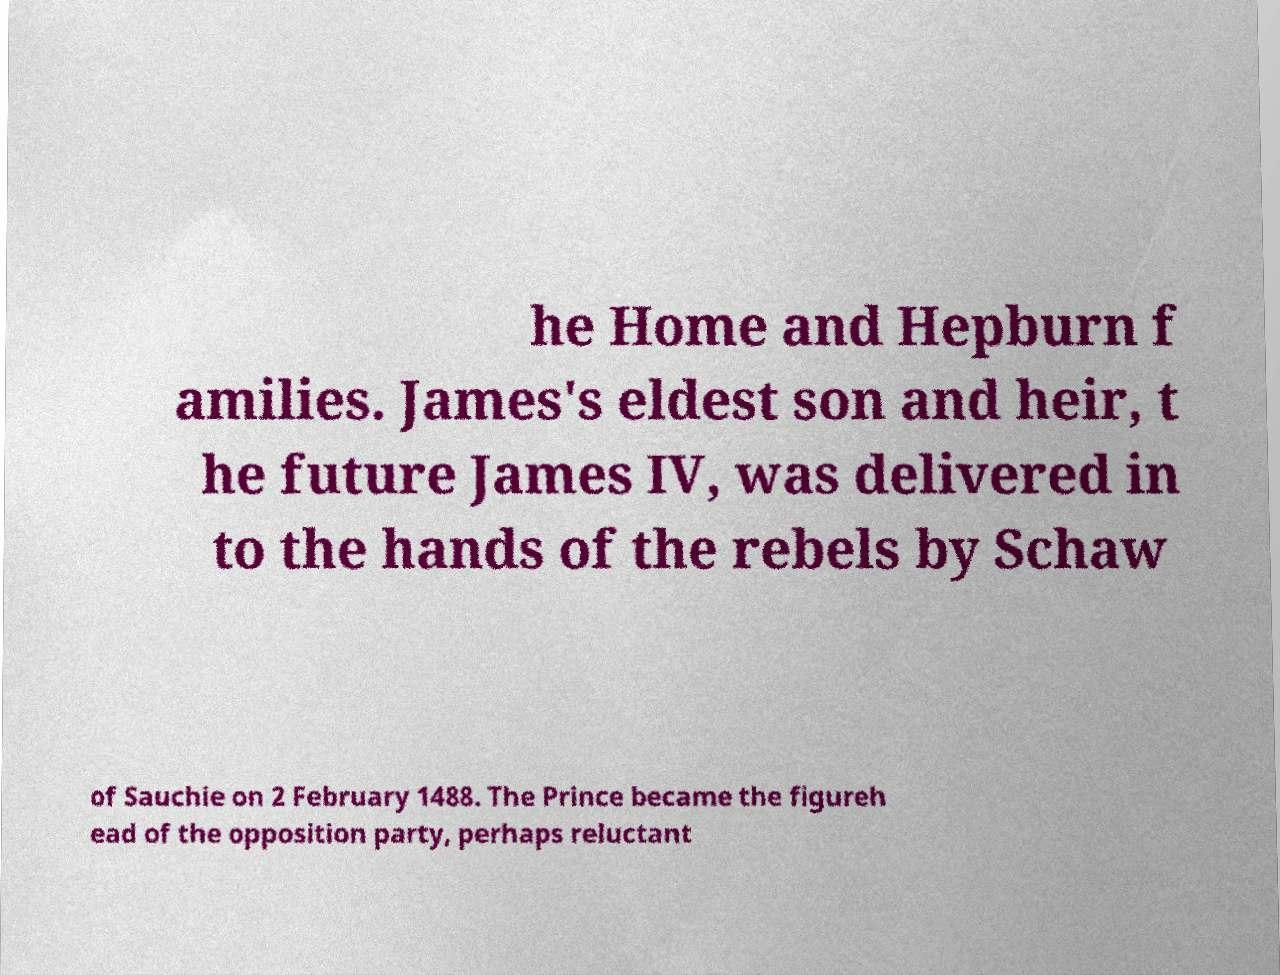For documentation purposes, I need the text within this image transcribed. Could you provide that? he Home and Hepburn f amilies. James's eldest son and heir, t he future James IV, was delivered in to the hands of the rebels by Schaw of Sauchie on 2 February 1488. The Prince became the figureh ead of the opposition party, perhaps reluctant 